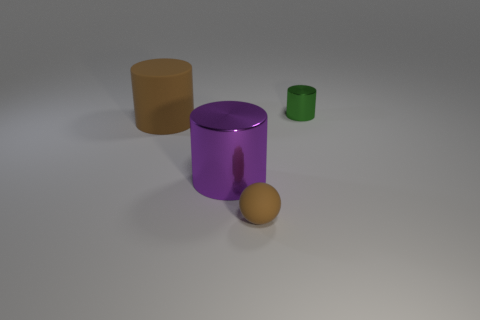Does the small rubber ball have the same color as the matte cylinder? No, the small rubber ball does not have the same color as the matte cylinder. The ball appears to be orange, whereas the cylinder is purple. 